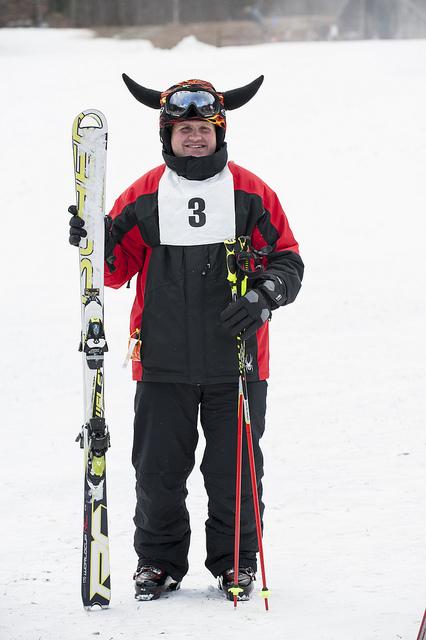What is the man wearing on his head?
Concise answer only. Horns. What number is on the skiers shirt?
Quick response, please. 3. Are the skis on his feet?
Be succinct. No. What number is he wearing?
Answer briefly. 3. Are there 1 or 2 ski's?
Answer briefly. 1. 